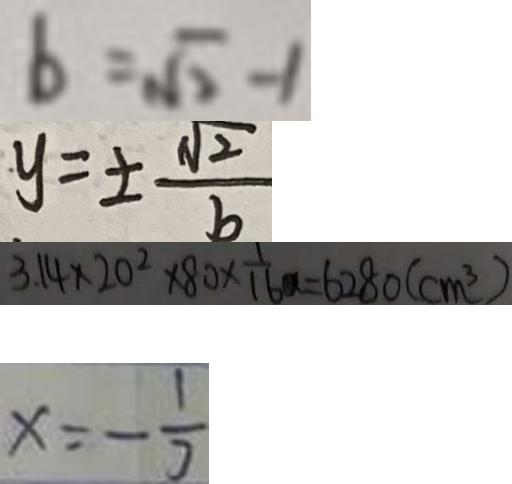Convert formula to latex. <formula><loc_0><loc_0><loc_500><loc_500>b = \sqrt { 2 } - 1 
 y = \pm \frac { \sqrt { 2 } } { b } 
 3 . 1 4 \times 2 0 ^ { 2 } \times 8 0 \times \frac { 1 } { 1 6 } a = 6 2 8 0 ( c m ^ { 3 } ) 
 x = - \frac { 1 } { 3 }</formula> 